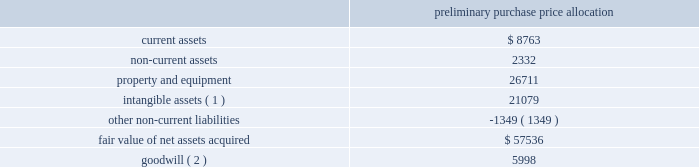American tower corporation and subsidiaries notes to consolidated financial statements ( 3 ) consists of customer-related intangibles of approximately $ 75.0 million and network location intangibles of approximately $ 72.7 million .
The customer-related intangibles and network location intangibles are being amortized on a straight-line basis over periods of up to 20 years .
( 4 ) the company expects that the goodwill recorded will be deductible for tax purposes .
The goodwill was allocated to the company 2019s international rental and management segment .
On september 12 , 2012 , the company entered into a definitive agreement to purchase up to approximately 348 additional communications sites from telef f3nica mexico .
On september 27 , 2012 and december 14 , 2012 , the company completed the purchase of 279 and 2 communications sites , for an aggregate purchase price of $ 63.5 million ( including value added tax of $ 8.8 million ) .
The table summarizes the preliminary allocation of the aggregate purchase consideration paid and the amounts of assets acquired and liabilities assumed based upon their estimated fair value at the date of acquisition ( in thousands ) : preliminary purchase price allocation .
( 1 ) consists of customer-related intangibles of approximately $ 10.7 million and network location intangibles of approximately $ 10.4 million .
The customer-related intangibles and network location intangibles are being amortized on a straight-line basis over periods of up to 20 years .
( 2 ) the company expects that the goodwill recorded will be deductible for tax purposes .
The goodwill was allocated to the company 2019s international rental and management segment .
On november 16 , 2012 , the company entered into an agreement to purchase up to 198 additional communications sites from telef f3nica mexico .
On december 14 , 2012 , the company completed the purchase of 188 communications sites , for an aggregate purchase price of $ 64.2 million ( including value added tax of $ 8.9 million ) . .
For acquired customer-related and network location intangibles , what is the expected annual amortization expenses , in millions? 
Computations: ((75.0 + 72.7) / 20)
Answer: 7.385. American tower corporation and subsidiaries notes to consolidated financial statements ( 3 ) consists of customer-related intangibles of approximately $ 75.0 million and network location intangibles of approximately $ 72.7 million .
The customer-related intangibles and network location intangibles are being amortized on a straight-line basis over periods of up to 20 years .
( 4 ) the company expects that the goodwill recorded will be deductible for tax purposes .
The goodwill was allocated to the company 2019s international rental and management segment .
On september 12 , 2012 , the company entered into a definitive agreement to purchase up to approximately 348 additional communications sites from telef f3nica mexico .
On september 27 , 2012 and december 14 , 2012 , the company completed the purchase of 279 and 2 communications sites , for an aggregate purchase price of $ 63.5 million ( including value added tax of $ 8.8 million ) .
The table summarizes the preliminary allocation of the aggregate purchase consideration paid and the amounts of assets acquired and liabilities assumed based upon their estimated fair value at the date of acquisition ( in thousands ) : preliminary purchase price allocation .
( 1 ) consists of customer-related intangibles of approximately $ 10.7 million and network location intangibles of approximately $ 10.4 million .
The customer-related intangibles and network location intangibles are being amortized on a straight-line basis over periods of up to 20 years .
( 2 ) the company expects that the goodwill recorded will be deductible for tax purposes .
The goodwill was allocated to the company 2019s international rental and management segment .
On november 16 , 2012 , the company entered into an agreement to purchase up to 198 additional communications sites from telef f3nica mexico .
On december 14 , 2012 , the company completed the purchase of 188 communications sites , for an aggregate purchase price of $ 64.2 million ( including value added tax of $ 8.9 million ) . .
What was the ratio of the customer-related intangibles to the network location intangibles included in the financial statements of american tower corporation and subsidiaries? 
Computations: (75.0 / 72.7)
Answer: 1.03164. American tower corporation and subsidiaries notes to consolidated financial statements ( 3 ) consists of customer-related intangibles of approximately $ 75.0 million and network location intangibles of approximately $ 72.7 million .
The customer-related intangibles and network location intangibles are being amortized on a straight-line basis over periods of up to 20 years .
( 4 ) the company expects that the goodwill recorded will be deductible for tax purposes .
The goodwill was allocated to the company 2019s international rental and management segment .
On september 12 , 2012 , the company entered into a definitive agreement to purchase up to approximately 348 additional communications sites from telef f3nica mexico .
On september 27 , 2012 and december 14 , 2012 , the company completed the purchase of 279 and 2 communications sites , for an aggregate purchase price of $ 63.5 million ( including value added tax of $ 8.8 million ) .
The table summarizes the preliminary allocation of the aggregate purchase consideration paid and the amounts of assets acquired and liabilities assumed based upon their estimated fair value at the date of acquisition ( in thousands ) : preliminary purchase price allocation .
( 1 ) consists of customer-related intangibles of approximately $ 10.7 million and network location intangibles of approximately $ 10.4 million .
The customer-related intangibles and network location intangibles are being amortized on a straight-line basis over periods of up to 20 years .
( 2 ) the company expects that the goodwill recorded will be deductible for tax purposes .
The goodwill was allocated to the company 2019s international rental and management segment .
On november 16 , 2012 , the company entered into an agreement to purchase up to 198 additional communications sites from telef f3nica mexico .
On december 14 , 2012 , the company completed the purchase of 188 communications sites , for an aggregate purchase price of $ 64.2 million ( including value added tax of $ 8.9 million ) . .
For the december 14 , 2012 purchase , what was the average cost of the communications sites acquired? 
Computations: ((64.2 * 1000000) / 188)
Answer: 341489.3617. American tower corporation and subsidiaries notes to consolidated financial statements ( 3 ) consists of customer-related intangibles of approximately $ 75.0 million and network location intangibles of approximately $ 72.7 million .
The customer-related intangibles and network location intangibles are being amortized on a straight-line basis over periods of up to 20 years .
( 4 ) the company expects that the goodwill recorded will be deductible for tax purposes .
The goodwill was allocated to the company 2019s international rental and management segment .
On september 12 , 2012 , the company entered into a definitive agreement to purchase up to approximately 348 additional communications sites from telef f3nica mexico .
On september 27 , 2012 and december 14 , 2012 , the company completed the purchase of 279 and 2 communications sites , for an aggregate purchase price of $ 63.5 million ( including value added tax of $ 8.8 million ) .
The table summarizes the preliminary allocation of the aggregate purchase consideration paid and the amounts of assets acquired and liabilities assumed based upon their estimated fair value at the date of acquisition ( in thousands ) : preliminary purchase price allocation .
( 1 ) consists of customer-related intangibles of approximately $ 10.7 million and network location intangibles of approximately $ 10.4 million .
The customer-related intangibles and network location intangibles are being amortized on a straight-line basis over periods of up to 20 years .
( 2 ) the company expects that the goodwill recorded will be deductible for tax purposes .
The goodwill was allocated to the company 2019s international rental and management segment .
On november 16 , 2012 , the company entered into an agreement to purchase up to 198 additional communications sites from telef f3nica mexico .
On december 14 , 2012 , the company completed the purchase of 188 communications sites , for an aggregate purchase price of $ 64.2 million ( including value added tax of $ 8.9 million ) . .
What was the ratio of the fair assets acquired to the fair value? 
Computations: ((21079 + (26711 + (8763 + 2332))) / 57536)
Answer: 1.02345. 